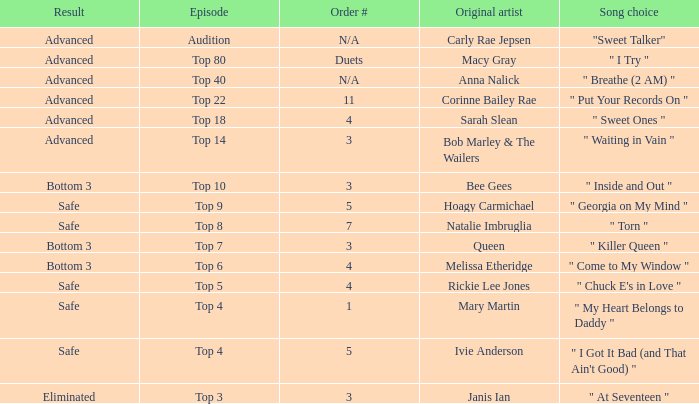What's the order number of the song originally performed by Rickie Lee Jones? 4.0. 